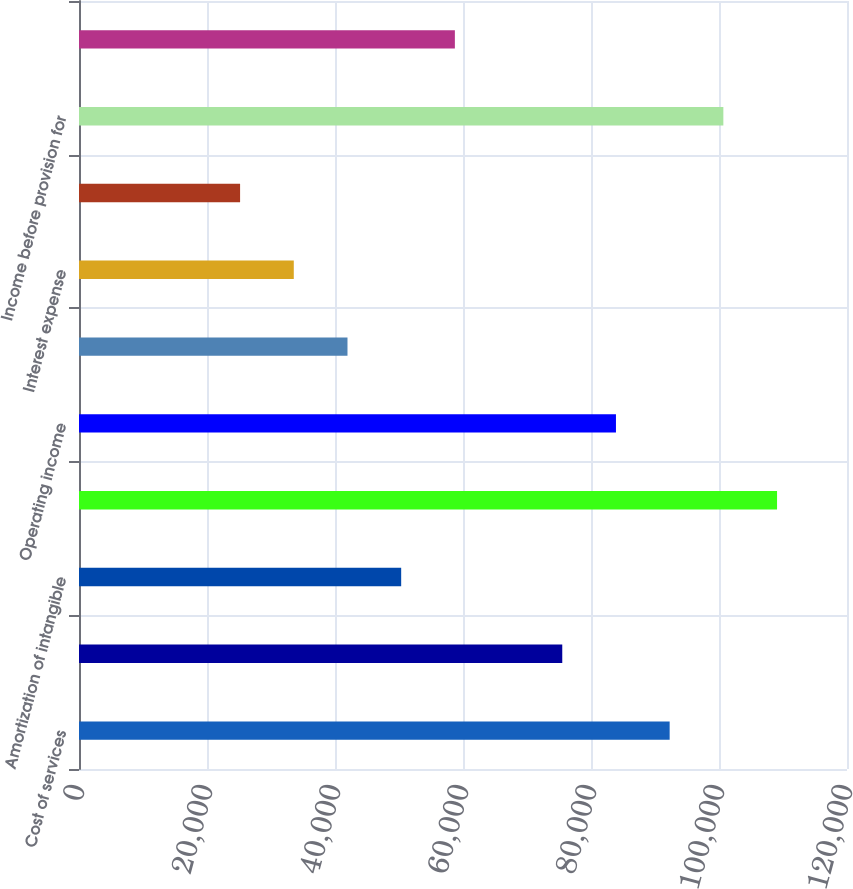Convert chart. <chart><loc_0><loc_0><loc_500><loc_500><bar_chart><fcel>Cost of services<fcel>Selling general and<fcel>Amortization of intangible<fcel>Total operating expenses<fcel>Operating income<fcel>Interest income<fcel>Interest expense<fcel>Other income<fcel>Income before provision for<fcel>Provision for income taxes<nl><fcel>92290<fcel>75510.1<fcel>50340.1<fcel>109070<fcel>83900<fcel>41950.1<fcel>33560.2<fcel>25170.2<fcel>100680<fcel>58730.1<nl></chart> 